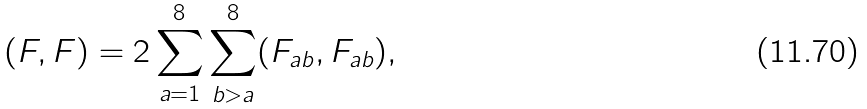<formula> <loc_0><loc_0><loc_500><loc_500>( F , F ) = 2 \sum _ { a = 1 } ^ { 8 } \sum _ { b > a } ^ { 8 } ( F _ { a b } , F _ { a b } ) ,</formula> 